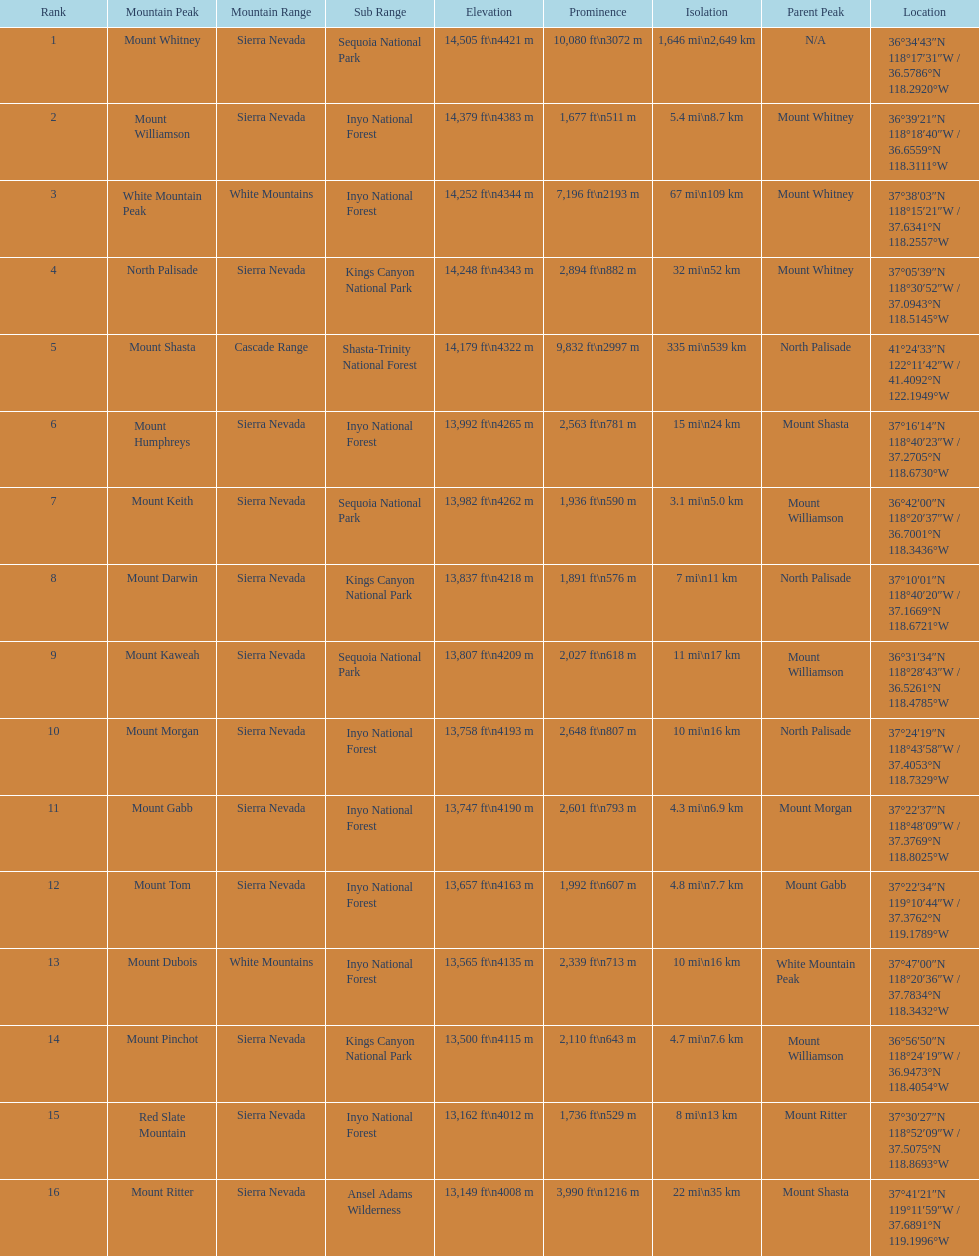Is the peak of mount keith above or below the peak of north palisade? Below. 